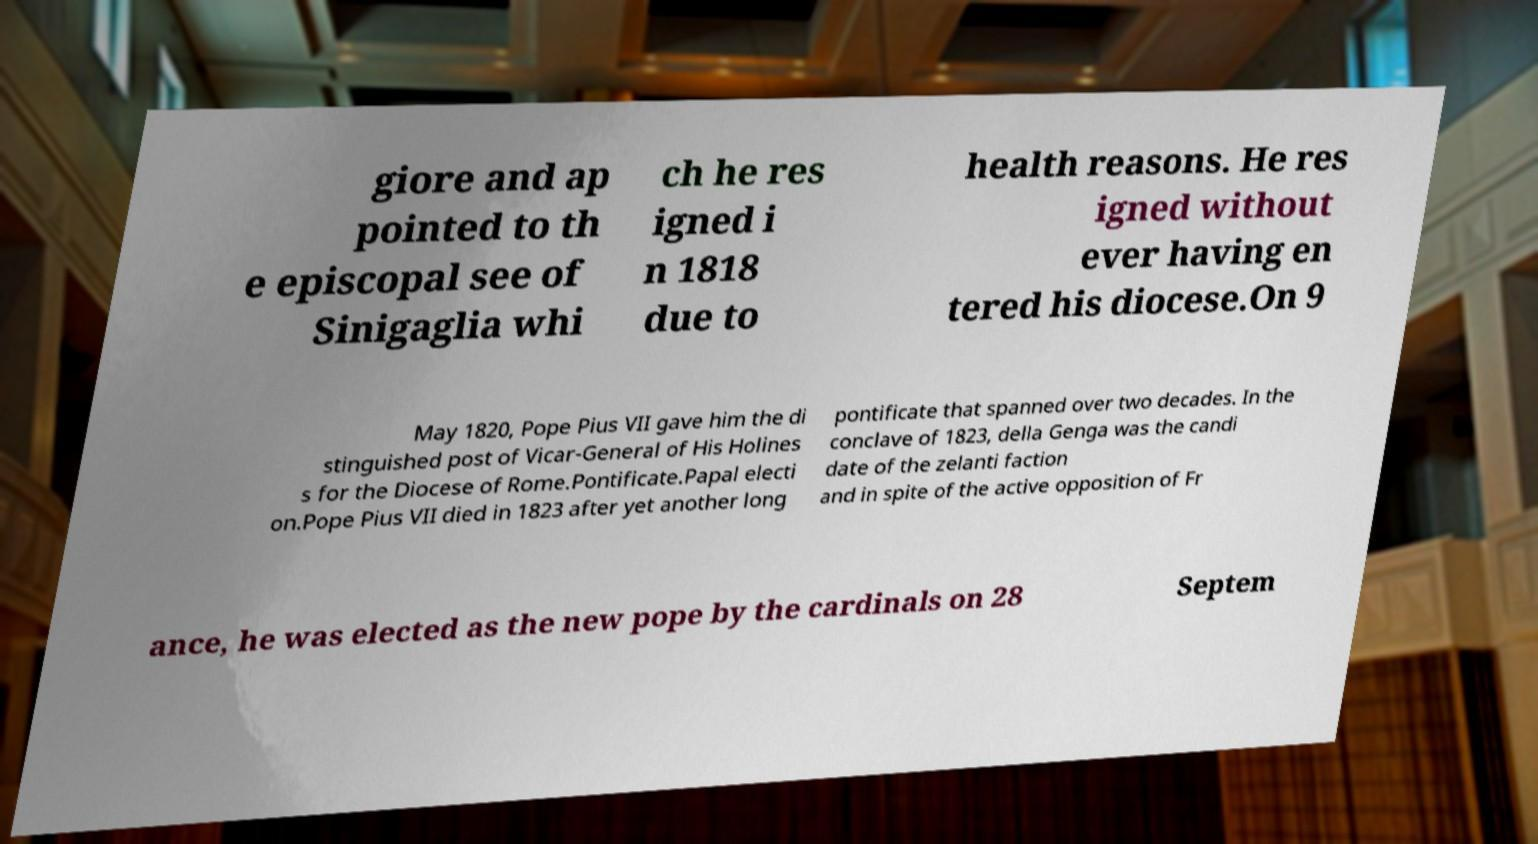I need the written content from this picture converted into text. Can you do that? giore and ap pointed to th e episcopal see of Sinigaglia whi ch he res igned i n 1818 due to health reasons. He res igned without ever having en tered his diocese.On 9 May 1820, Pope Pius VII gave him the di stinguished post of Vicar-General of His Holines s for the Diocese of Rome.Pontificate.Papal electi on.Pope Pius VII died in 1823 after yet another long pontificate that spanned over two decades. In the conclave of 1823, della Genga was the candi date of the zelanti faction and in spite of the active opposition of Fr ance, he was elected as the new pope by the cardinals on 28 Septem 